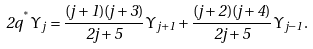Convert formula to latex. <formula><loc_0><loc_0><loc_500><loc_500>2 q ^ { ^ { * } } { \mathit \Upsilon } _ { j } = \frac { ( j + 1 ) ( j + 3 ) } { 2 j + 5 } { \mathit \Upsilon } _ { j + 1 } + \frac { ( j + 2 ) ( j + 4 ) } { 2 j + 5 } { \mathit \Upsilon } _ { j - 1 } .</formula> 